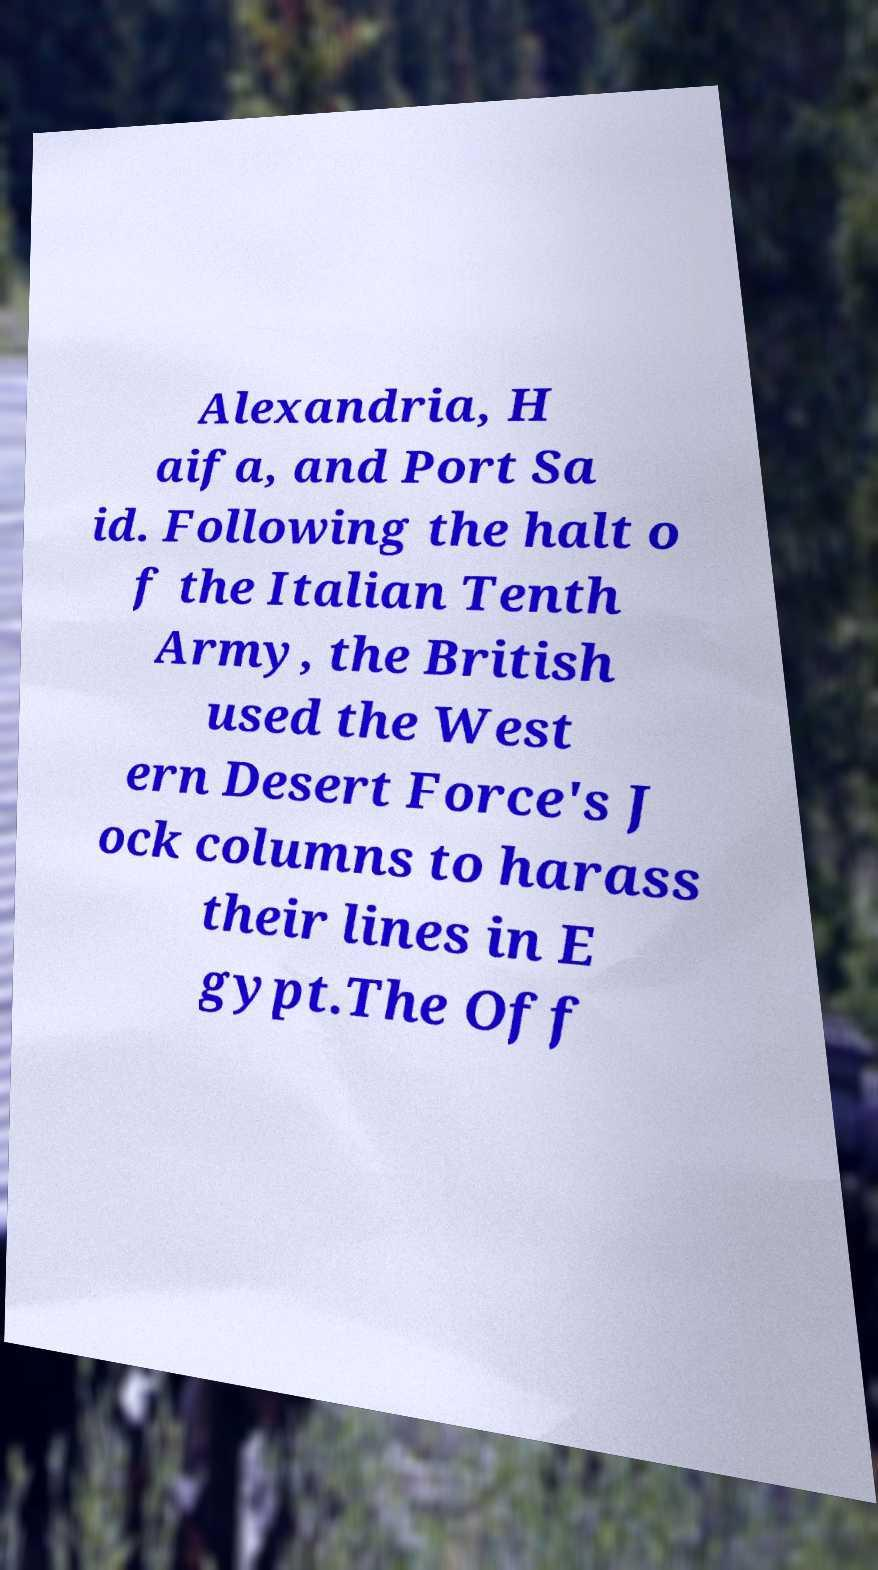There's text embedded in this image that I need extracted. Can you transcribe it verbatim? Alexandria, H aifa, and Port Sa id. Following the halt o f the Italian Tenth Army, the British used the West ern Desert Force's J ock columns to harass their lines in E gypt.The Off 